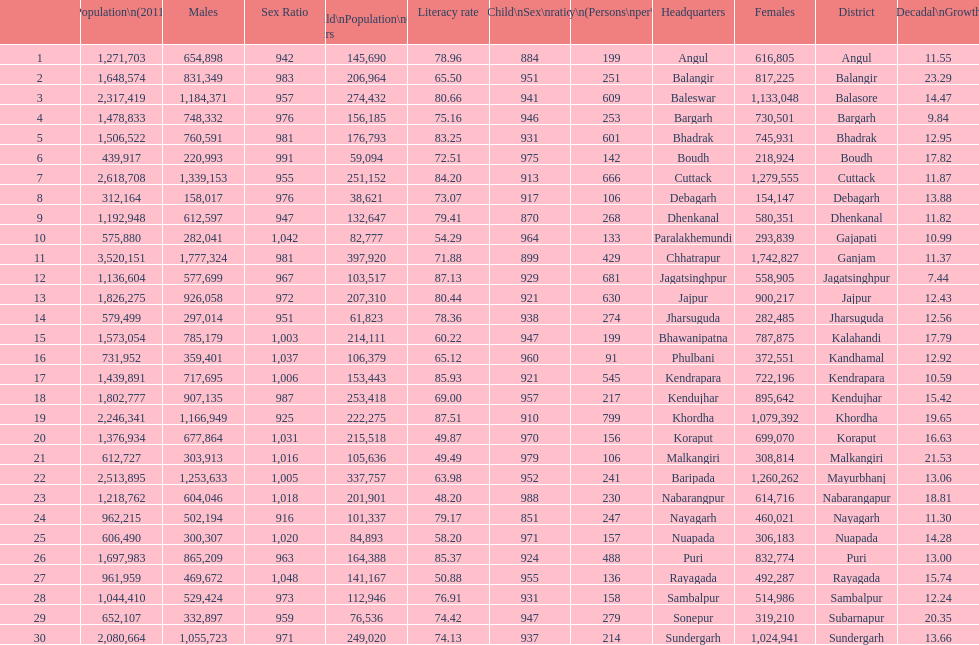Which district had least population growth from 2001-2011? Jagatsinghpur. 